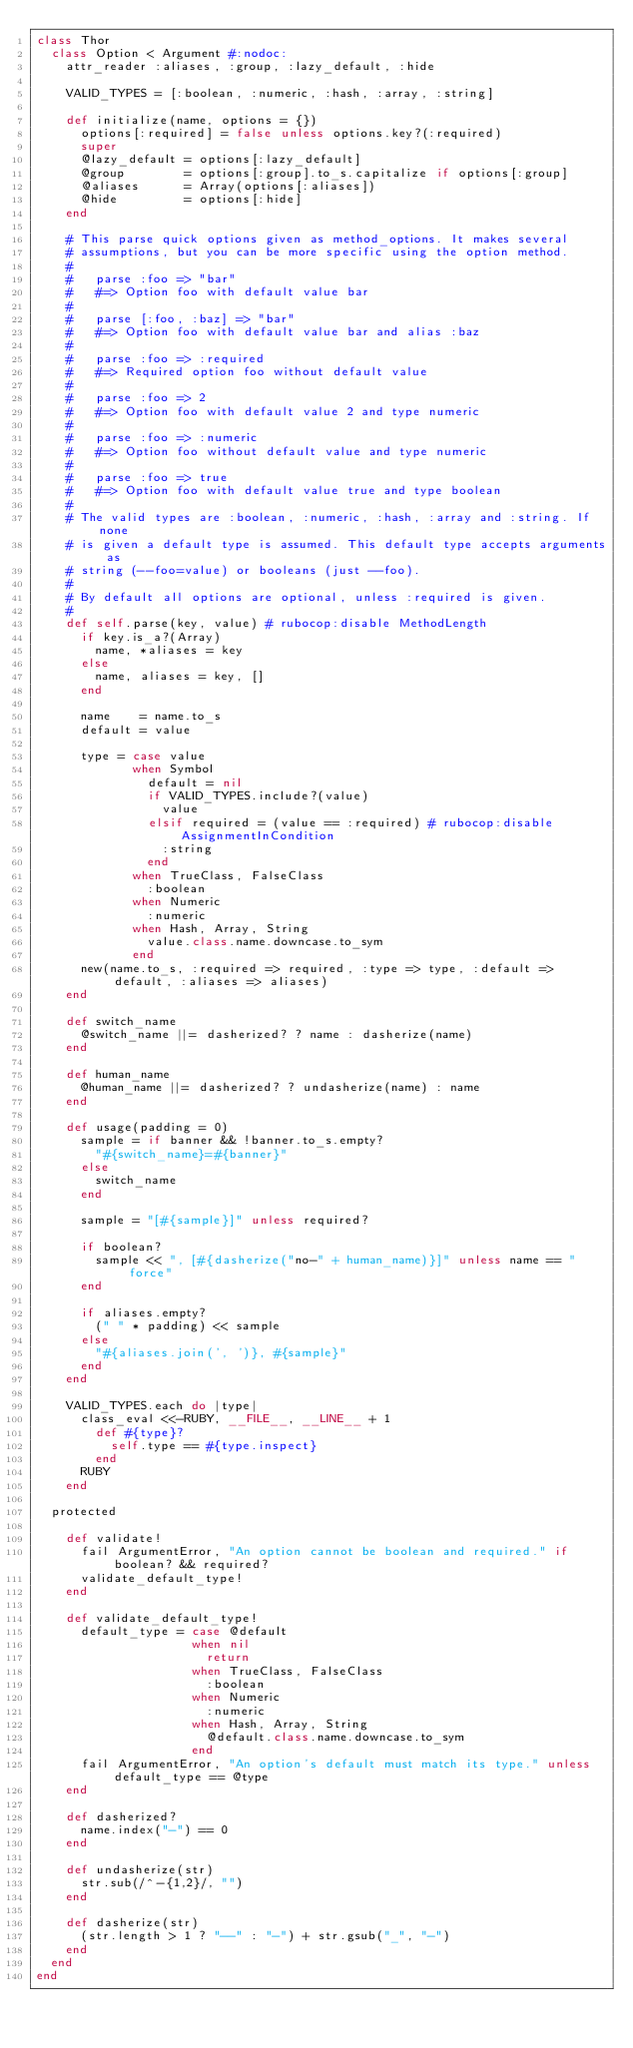<code> <loc_0><loc_0><loc_500><loc_500><_Ruby_>class Thor
  class Option < Argument #:nodoc:
    attr_reader :aliases, :group, :lazy_default, :hide

    VALID_TYPES = [:boolean, :numeric, :hash, :array, :string]

    def initialize(name, options = {})
      options[:required] = false unless options.key?(:required)
      super
      @lazy_default = options[:lazy_default]
      @group        = options[:group].to_s.capitalize if options[:group]
      @aliases      = Array(options[:aliases])
      @hide         = options[:hide]
    end

    # This parse quick options given as method_options. It makes several
    # assumptions, but you can be more specific using the option method.
    #
    #   parse :foo => "bar"
    #   #=> Option foo with default value bar
    #
    #   parse [:foo, :baz] => "bar"
    #   #=> Option foo with default value bar and alias :baz
    #
    #   parse :foo => :required
    #   #=> Required option foo without default value
    #
    #   parse :foo => 2
    #   #=> Option foo with default value 2 and type numeric
    #
    #   parse :foo => :numeric
    #   #=> Option foo without default value and type numeric
    #
    #   parse :foo => true
    #   #=> Option foo with default value true and type boolean
    #
    # The valid types are :boolean, :numeric, :hash, :array and :string. If none
    # is given a default type is assumed. This default type accepts arguments as
    # string (--foo=value) or booleans (just --foo).
    #
    # By default all options are optional, unless :required is given.
    #
    def self.parse(key, value) # rubocop:disable MethodLength
      if key.is_a?(Array)
        name, *aliases = key
      else
        name, aliases = key, []
      end

      name    = name.to_s
      default = value

      type = case value
             when Symbol
               default = nil
               if VALID_TYPES.include?(value)
                 value
               elsif required = (value == :required) # rubocop:disable AssignmentInCondition
                 :string
               end
             when TrueClass, FalseClass
               :boolean
             when Numeric
               :numeric
             when Hash, Array, String
               value.class.name.downcase.to_sym
             end
      new(name.to_s, :required => required, :type => type, :default => default, :aliases => aliases)
    end

    def switch_name
      @switch_name ||= dasherized? ? name : dasherize(name)
    end

    def human_name
      @human_name ||= dasherized? ? undasherize(name) : name
    end

    def usage(padding = 0)
      sample = if banner && !banner.to_s.empty?
        "#{switch_name}=#{banner}"
      else
        switch_name
      end

      sample = "[#{sample}]" unless required?

      if boolean?
        sample << ", [#{dasherize("no-" + human_name)}]" unless name == "force"
      end

      if aliases.empty?
        (" " * padding) << sample
      else
        "#{aliases.join(', ')}, #{sample}"
      end
    end

    VALID_TYPES.each do |type|
      class_eval <<-RUBY, __FILE__, __LINE__ + 1
        def #{type}?
          self.type == #{type.inspect}
        end
      RUBY
    end

  protected

    def validate!
      fail ArgumentError, "An option cannot be boolean and required." if boolean? && required?
      validate_default_type!
    end

    def validate_default_type!
      default_type = case @default
                     when nil
                       return
                     when TrueClass, FalseClass
                       :boolean
                     when Numeric
                       :numeric
                     when Hash, Array, String
                       @default.class.name.downcase.to_sym
                     end
      fail ArgumentError, "An option's default must match its type." unless default_type == @type
    end

    def dasherized?
      name.index("-") == 0
    end

    def undasherize(str)
      str.sub(/^-{1,2}/, "")
    end

    def dasherize(str)
      (str.length > 1 ? "--" : "-") + str.gsub("_", "-")
    end
  end
end
</code> 